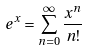Convert formula to latex. <formula><loc_0><loc_0><loc_500><loc_500>e ^ { x } = \sum _ { n = 0 } ^ { \infty } \frac { x ^ { n } } { n ! }</formula> 